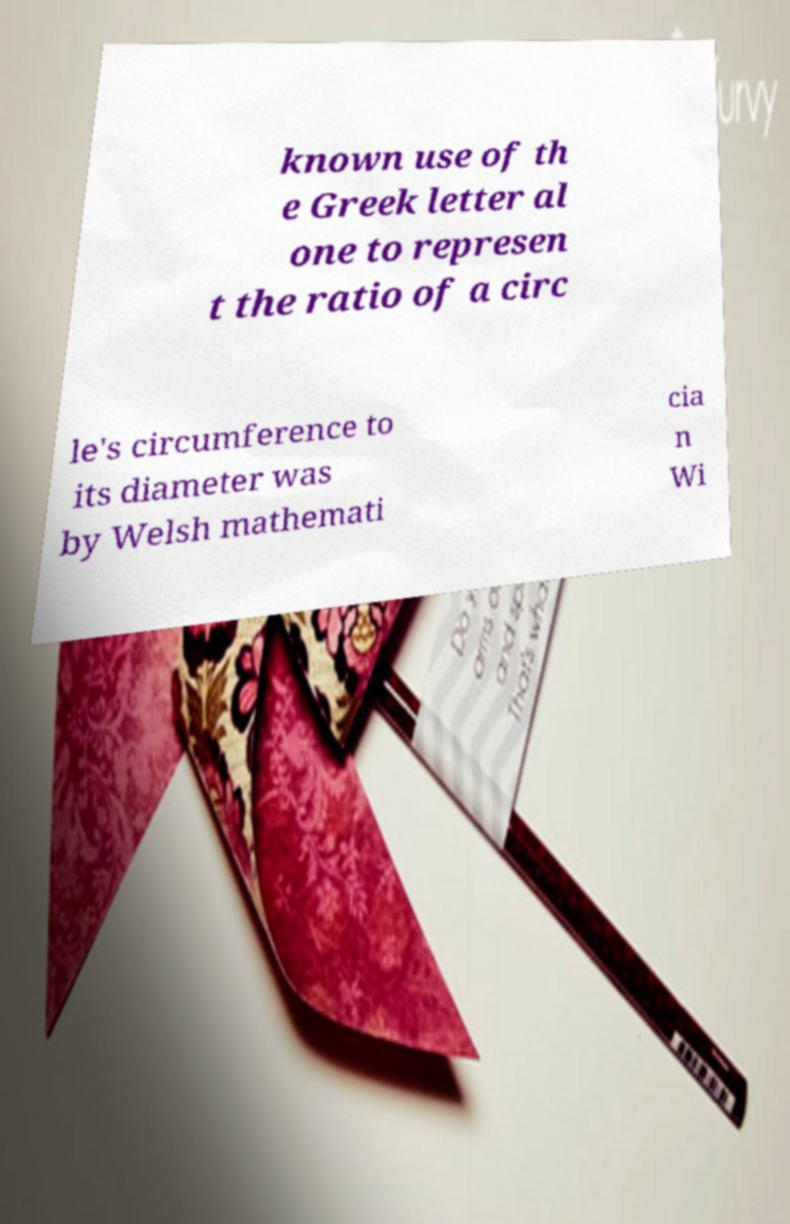Please identify and transcribe the text found in this image. known use of th e Greek letter al one to represen t the ratio of a circ le's circumference to its diameter was by Welsh mathemati cia n Wi 